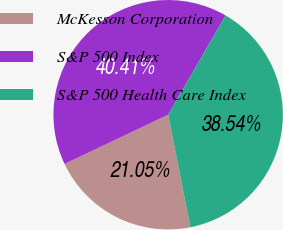Convert chart. <chart><loc_0><loc_0><loc_500><loc_500><pie_chart><fcel>McKesson Corporation<fcel>S&P 500 Index<fcel>S&P 500 Health Care Index<nl><fcel>21.05%<fcel>40.41%<fcel>38.54%<nl></chart> 